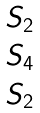Convert formula to latex. <formula><loc_0><loc_0><loc_500><loc_500>\begin{matrix} S _ { 2 } \\ S _ { 4 } \\ S _ { 2 } \end{matrix}</formula> 